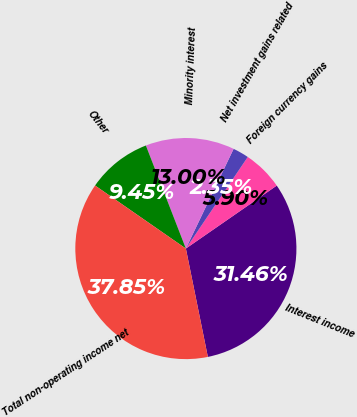<chart> <loc_0><loc_0><loc_500><loc_500><pie_chart><fcel>Interest income<fcel>Foreign currency gains<fcel>Net investment gains related<fcel>Minority interest<fcel>Other<fcel>Total non-operating income net<nl><fcel>31.46%<fcel>5.9%<fcel>2.35%<fcel>13.0%<fcel>9.45%<fcel>37.85%<nl></chart> 